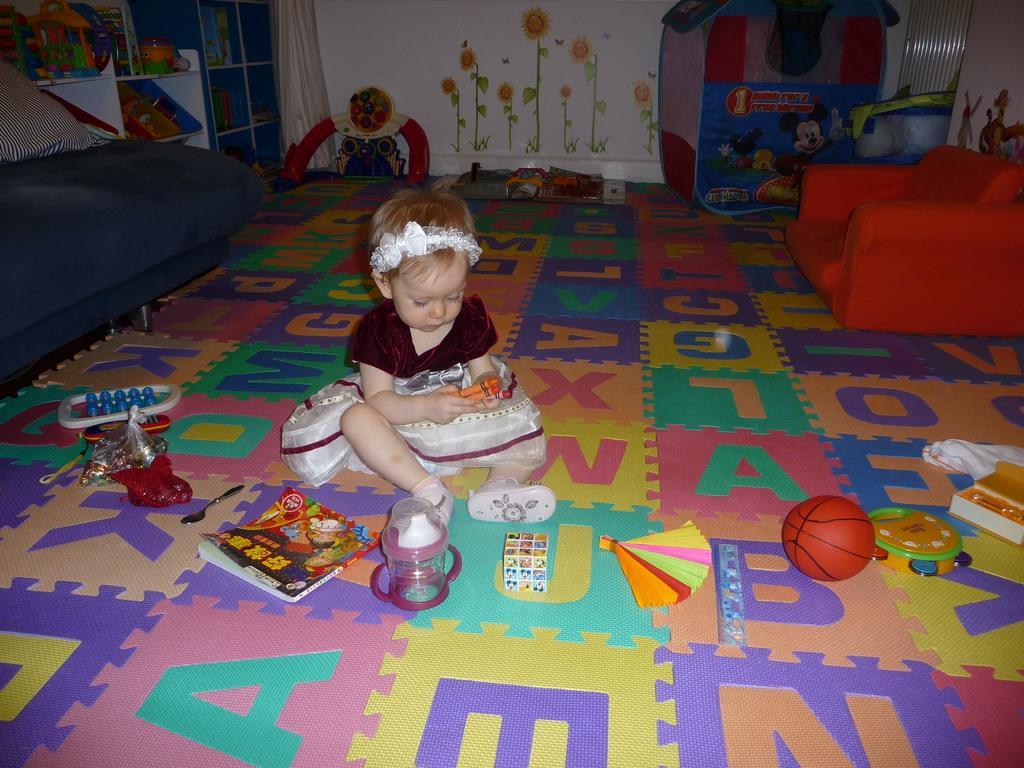Please provide a concise description of this image. In the image we can see there is a girl who is sitting on floor and there are toys, book, ball all around her. 